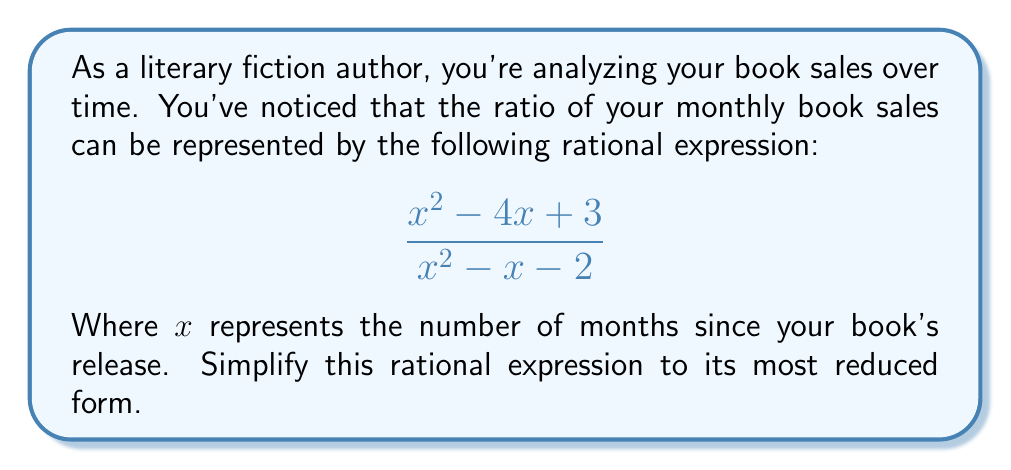What is the answer to this math problem? To simplify this rational expression, we'll follow these steps:

1) First, let's factor both the numerator and denominator:

   Numerator: $x^2 - 4x + 3 = (x - 3)(x - 1)$
   Denominator: $x^2 - x - 2 = (x + 1)(x - 2)$

2) Now our expression looks like this:

   $$\frac{(x - 3)(x - 1)}{(x + 1)(x - 2)}$$

3) We can see that there are no common factors between the numerator and denominator, so this is the most simplified form of the rational expression.

4) However, we need to consider the domain of this function. The denominator cannot equal zero, so:

   $x + 1 \neq 0$ and $x - 2 \neq 0$
   $x \neq -1$ and $x \neq 2$

5) Therefore, the domain is all real numbers except -1 and 2, which we can write as $x \in \mathbb{R}, x \neq -1, x \neq 2$.
Answer: $$\frac{(x - 3)(x - 1)}{(x + 1)(x - 2)}, \quad x \in \mathbb{R}, x \neq -1, x \neq 2$$ 